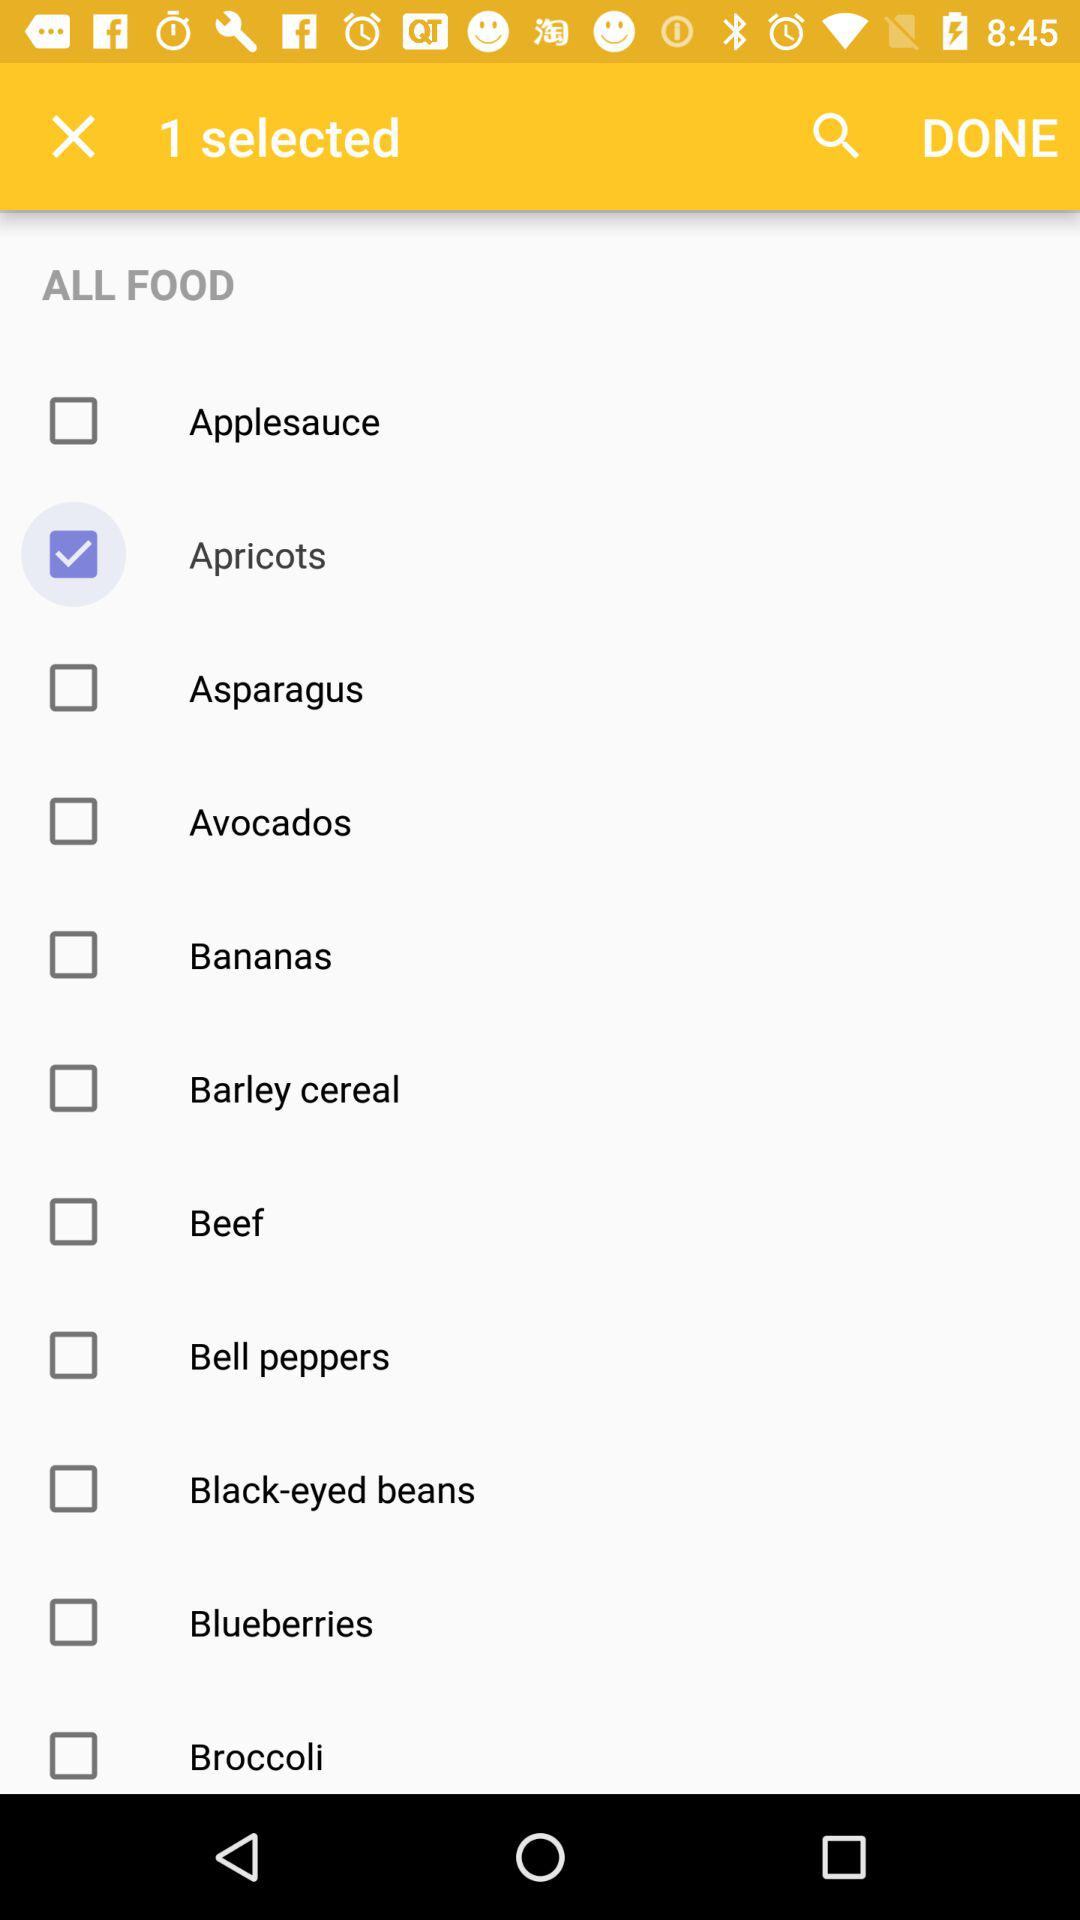What are the available options? The available options are "Applesauce", "Apricots", "Asparagus", "Avocados", "Bananas", "Barley cereal", "Beef", "Bell peppers", "Black-eyed beans", "Blueberries" and "Broccoli". 